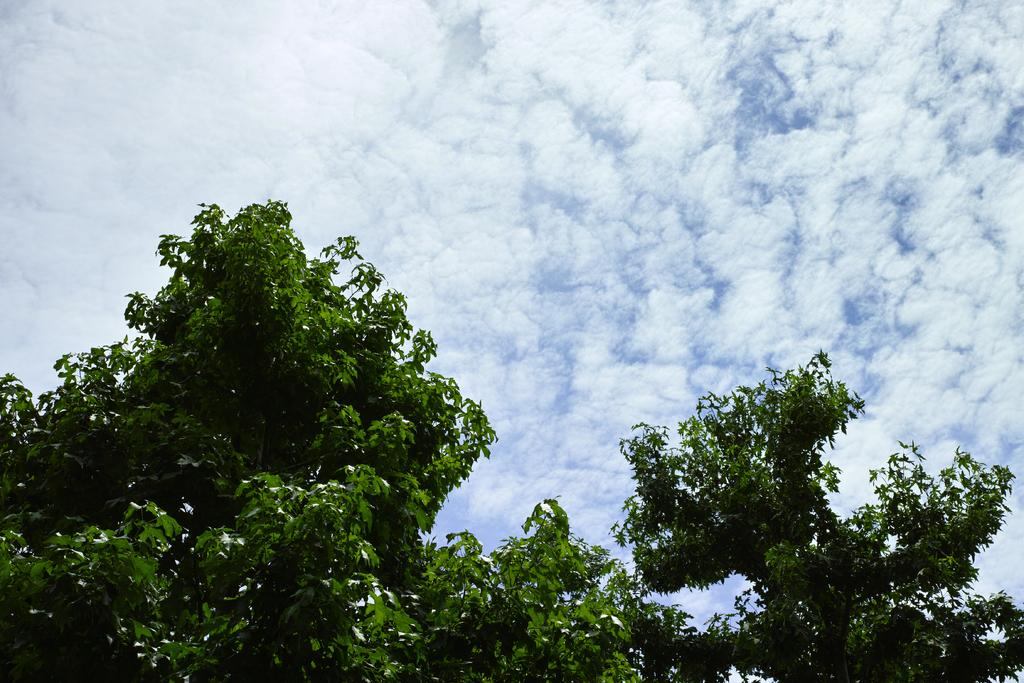What type of natural element is present in the image? There is a tree in the image. How would you describe the sky in the image? The sky is clear and a bit cloudy. What type of crime is being committed in the image? There is no crime being committed in the image; it features a tree and a clear sky with some clouds. What color is the bead hanging from the tree in the image? There is no bead present in the image. 